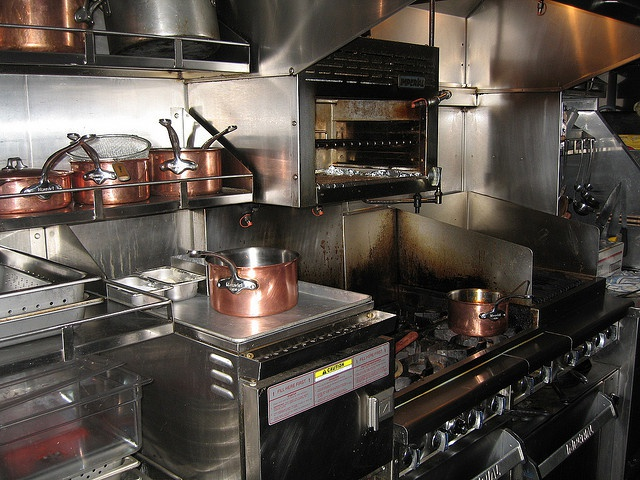Describe the objects in this image and their specific colors. I can see oven in black, gray, and maroon tones, oven in black, lightgray, gray, and darkgray tones, oven in black, gray, and darkgray tones, bowl in black, maroon, and gray tones, and spoon in black and gray tones in this image. 